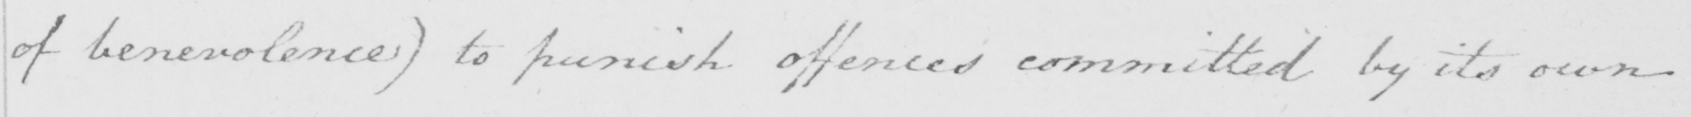What does this handwritten line say? of benevolence )  to punish offences committed by its own 